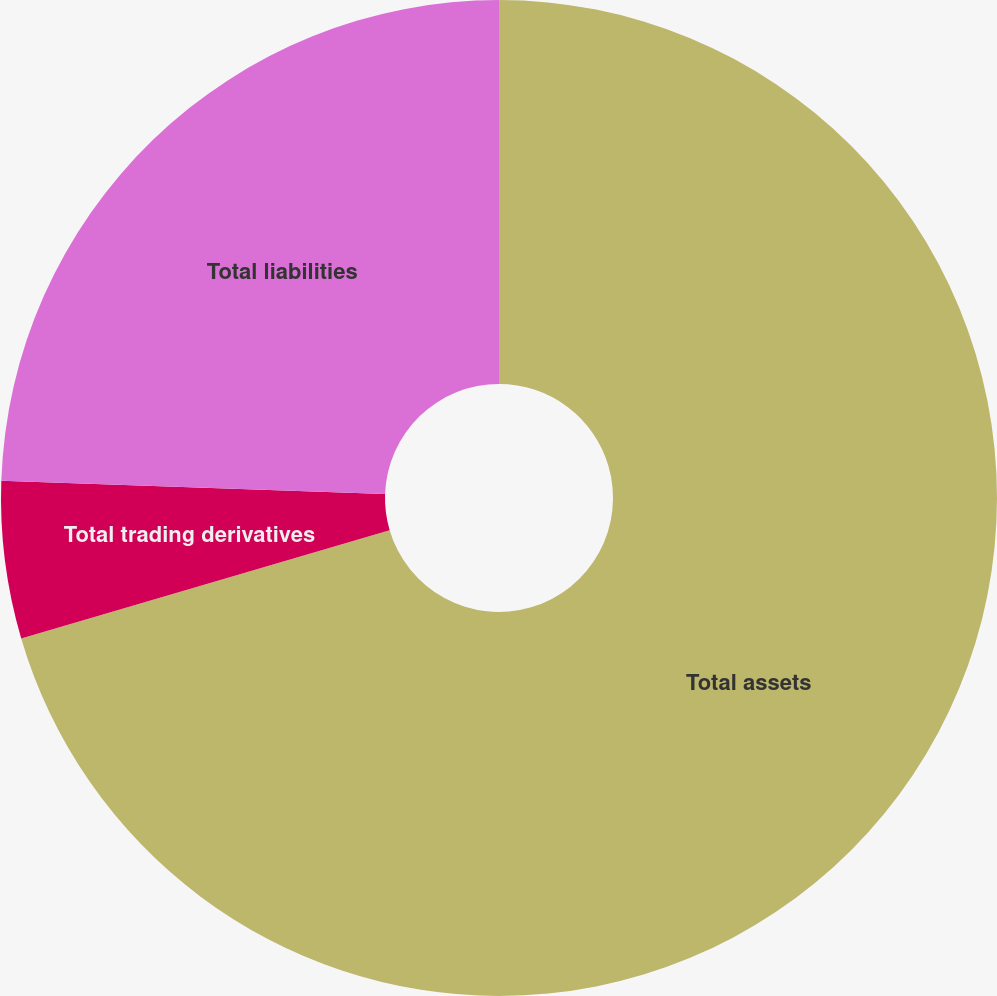Convert chart to OTSL. <chart><loc_0><loc_0><loc_500><loc_500><pie_chart><fcel>Total assets<fcel>Total trading derivatives<fcel>Total liabilities<nl><fcel>70.45%<fcel>5.1%<fcel>24.45%<nl></chart> 